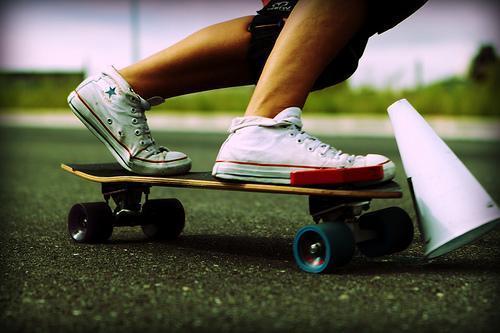How many feet are in the photo?
Give a very brief answer. 2. 